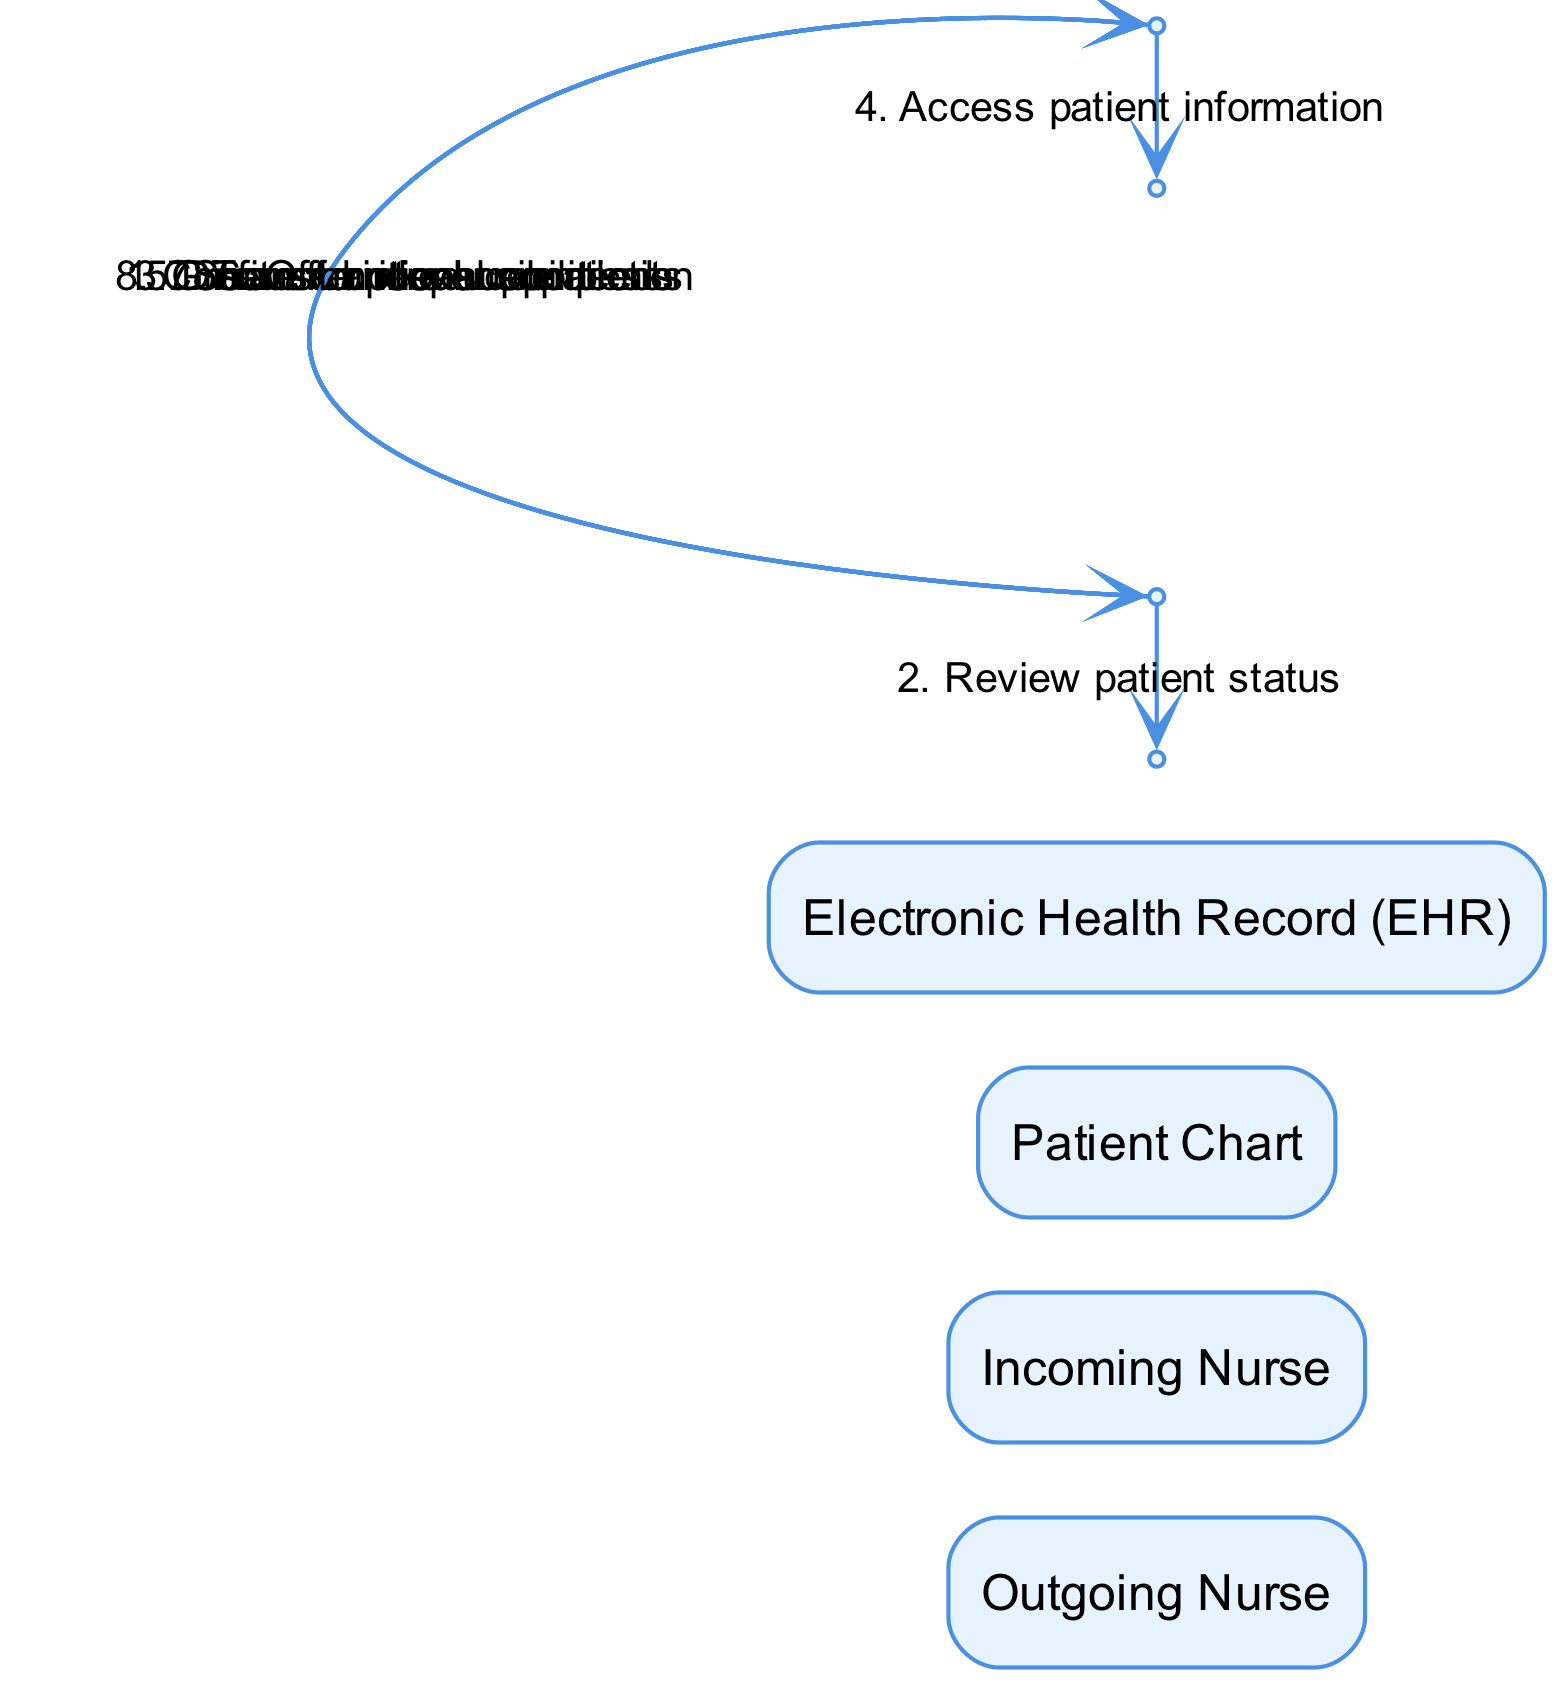What are the actors involved in the handover protocol? The diagram lists four actors: Outgoing Nurse, Incoming Nurse, Patient Chart, and Electronic Health Record (EHR). These actors are essential in the handover process.
Answer: Outgoing Nurse, Incoming Nurse, Patient Chart, Electronic Health Record (EHR) How many messages are exchanged between the nurses? There are a total of eight messages exchanged between the Outgoing Nurse and Incoming Nurse regarding patient information and responsibilities. We can count them visually in the sequence of events.
Answer: Eight What is the first message exchanged in the sequence? The first message from the Outgoing Nurse to the Incoming Nurse is a greeting and introduction of patients, as seen in the initial step of the sequence.
Answer: Greet and introduce patients Which actor accesses the Electronic Health Record? The Incoming Nurse is the actor who accesses the Electronic Health Record, as shown in the sequence where the Incoming Nurse interacts with the EHR to retrieve patient information.
Answer: Incoming Nurse What message follows the discussion of critical care needs? After discussing critical care needs, the Outgoing Nurse shares emotional concerns with the Incoming Nurse, making this the next logical step in their conversation, as indicated in the diagram.
Answer: Share emotional concerns Which messages focus on emotional support? The messages that focus on emotional support include "Share emotional concerns" from the Outgoing Nurse and "Offer peer support" from the Incoming Nurse. Both messages highlight the importance of emotional wellbeing during the handover process.
Answer: Share emotional concerns, Offer peer support What is the last confirmation step in the handover process? The final confirmation step occurs when the Incoming Nurse confirms the handover completion to the Outgoing Nurse, signaling the end of the transfer of responsibilities. This is crucial for ensuring the process is complete.
Answer: Confirm handover completion How many interactions occur before transferring responsibilities? There are five interactions before transferring responsibilities, which involve different messages exchanged between the nurses, including greetings, status reviews, discussions of care needs, and emotional support. All these steps occur before the responsibilities transfer.
Answer: Five 